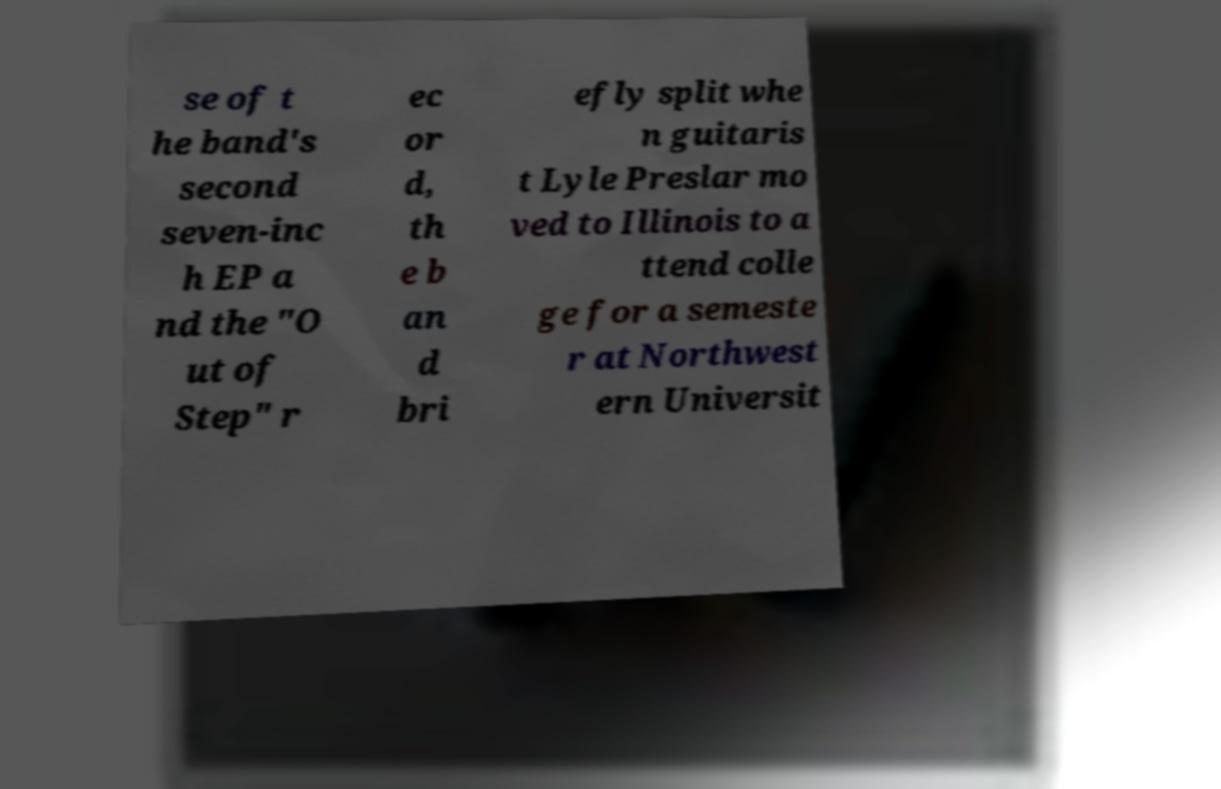There's text embedded in this image that I need extracted. Can you transcribe it verbatim? se of t he band's second seven-inc h EP a nd the "O ut of Step" r ec or d, th e b an d bri efly split whe n guitaris t Lyle Preslar mo ved to Illinois to a ttend colle ge for a semeste r at Northwest ern Universit 